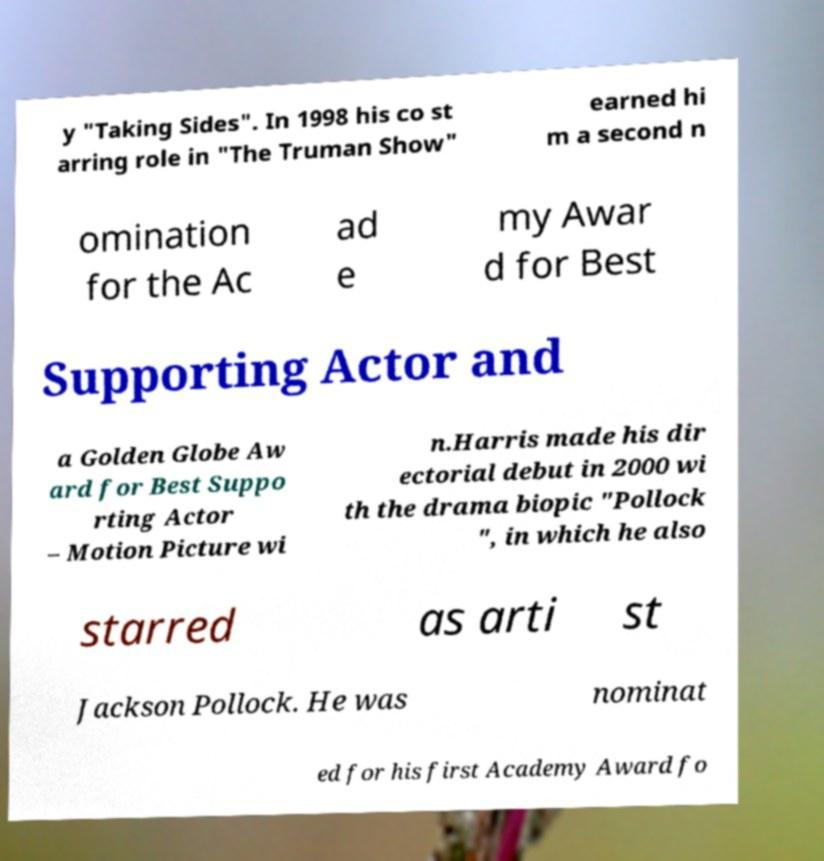Please identify and transcribe the text found in this image. y "Taking Sides". In 1998 his co st arring role in "The Truman Show" earned hi m a second n omination for the Ac ad e my Awar d for Best Supporting Actor and a Golden Globe Aw ard for Best Suppo rting Actor – Motion Picture wi n.Harris made his dir ectorial debut in 2000 wi th the drama biopic "Pollock ", in which he also starred as arti st Jackson Pollock. He was nominat ed for his first Academy Award fo 